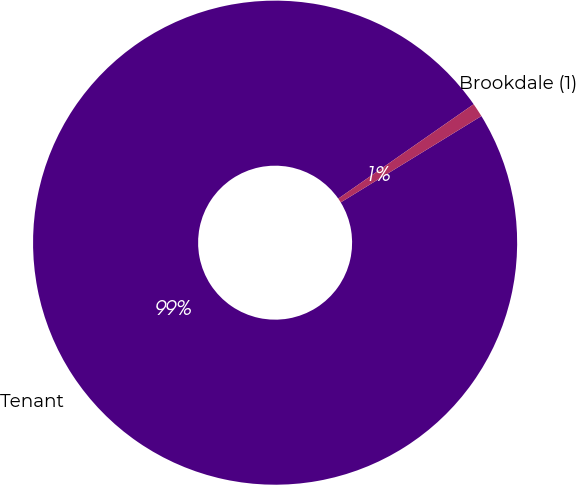Convert chart. <chart><loc_0><loc_0><loc_500><loc_500><pie_chart><fcel>Tenant<fcel>Brookdale (1)<nl><fcel>99.07%<fcel>0.93%<nl></chart> 